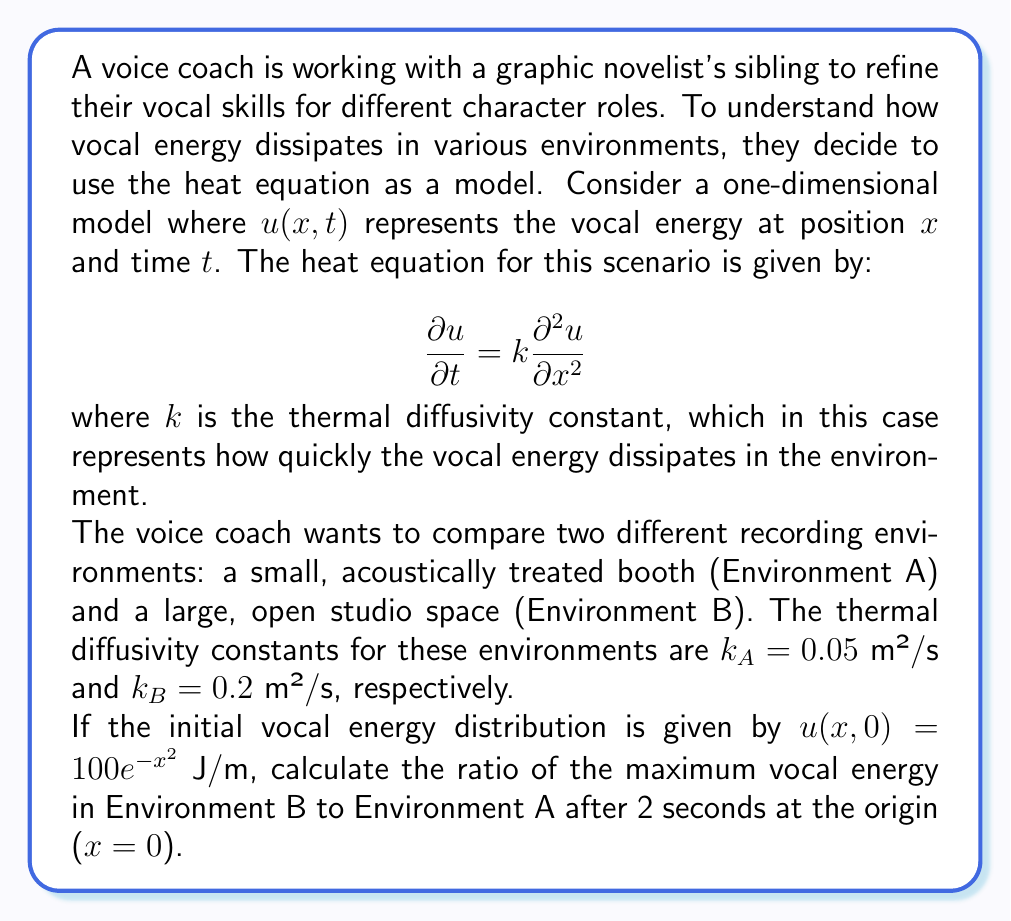Could you help me with this problem? To solve this problem, we need to use the solution to the heat equation for an initial Gaussian distribution. The solution for the heat equation with an initial condition $u(x,0) = Ae^{-ax^2}$ is:

$$u(x,t) = \frac{A}{\sqrt{1 + 4akt}} \exp\left(-\frac{ax^2}{1 + 4akt}\right)$$

Where $A$ is the initial amplitude and $a$ is the initial spread parameter.

In our case, $A = 100$ J/m and $a = 1$ m⁻².

For Environment A:
$$u_A(0,2) = \frac{100}{\sqrt{1 + 4(1)(0.05)(2)}} = \frac{100}{\sqrt{1.4}} \approx 84.52 \text{ J/m}$$

For Environment B:
$$u_B(0,2) = \frac{100}{\sqrt{1 + 4(1)(0.2)(2)}} = \frac{100}{\sqrt{2.6}} \approx 62.02 \text{ J/m}$$

The ratio of the maximum vocal energy in Environment B to Environment A after 2 seconds is:

$$\frac{u_B(0,2)}{u_A(0,2)} = \frac{62.02}{84.52} \approx 0.7338$$
Answer: The ratio of the maximum vocal energy in Environment B to Environment A after 2 seconds at the origin is approximately 0.7338. 